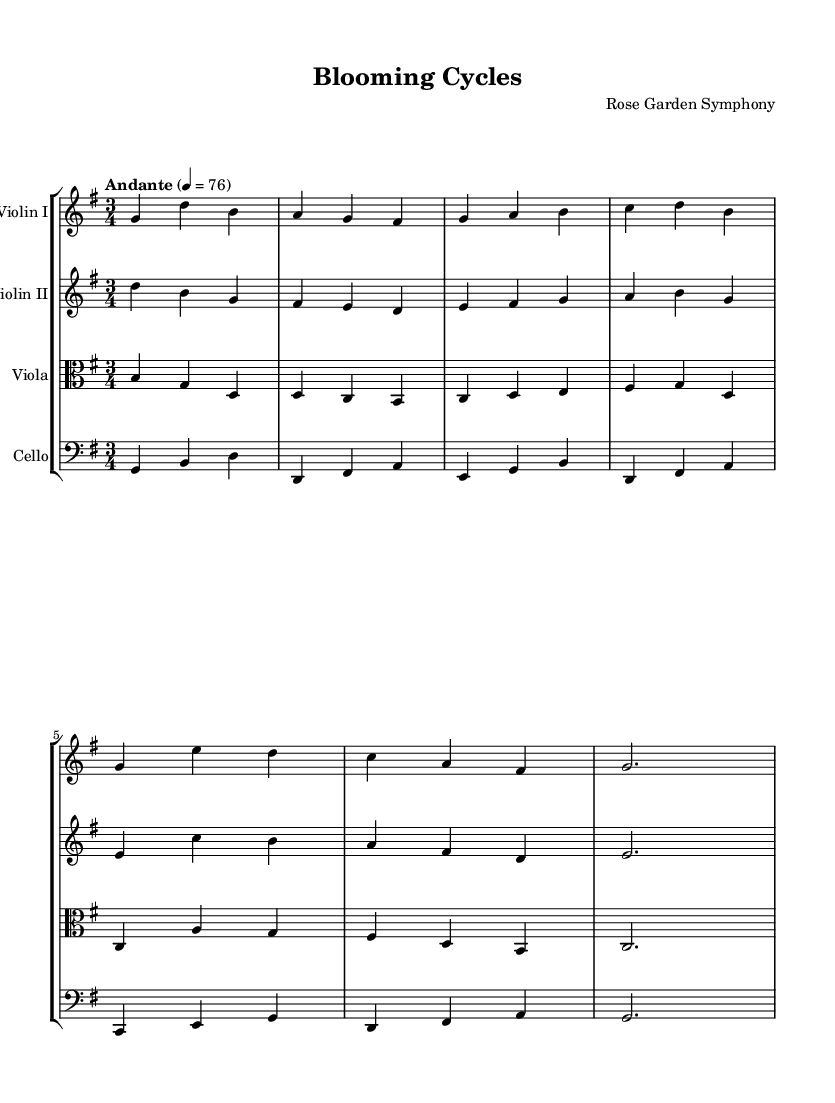What is the key signature of this music? The key signature is indicated at the beginning of the staff, showing one sharp, which denotes that the piece is in G major.
Answer: G major What is the time signature of this music? The time signature is notated as three beats per measure, which can be seen at the beginning of the score, indicating a 3/4 time signature.
Answer: 3/4 What is the tempo marking for this piece? The tempo marking is indicated with the term "Andante," which specifies a moderate walking pace at 76 beats per minute.
Answer: Andante How many instruments are used in this symphony? The score shows four separate staves, each labeled for a specific instrument: Violin I, Violin II, Viola, and Cello, making a total of four instruments.
Answer: Four What is the first note played by the Violin I? The first note in the Violin I staff is a G which is specified at the beginning of the measure.
Answer: G Which instrument has the clef marking indicated as "alto"? The Viola staff includes a clef marking at the beginning that indicates it is set in the alto clef, showing that this instrument is to be played with that specific clef.
Answer: Viola What rhythmic pattern does the cello follow in the first measure? The cello's first measure contains quarter notes, indicated by the note values shown on the staff, following a pattern of G, B, D.
Answer: Quarter notes 